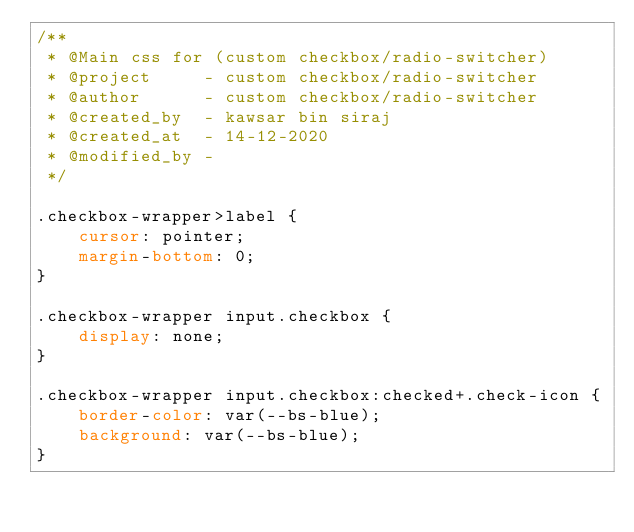Convert code to text. <code><loc_0><loc_0><loc_500><loc_500><_CSS_>/**
 * @Main css for (custom checkbox/radio-switcher)
 * @project     - custom checkbox/radio-switcher
 * @author      - custom checkbox/radio-switcher
 * @created_by  - kawsar bin siraj
 * @created_at  - 14-12-2020
 * @modified_by -
 */

.checkbox-wrapper>label {
    cursor: pointer;
    margin-bottom: 0;
}

.checkbox-wrapper input.checkbox {
    display: none;
}

.checkbox-wrapper input.checkbox:checked+.check-icon {
    border-color: var(--bs-blue);
    background: var(--bs-blue);
}
</code> 